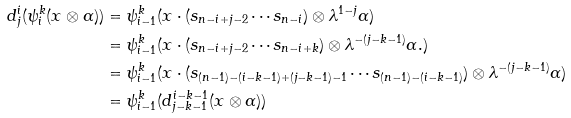<formula> <loc_0><loc_0><loc_500><loc_500>d ^ { i } _ { j } ( \psi ^ { k } _ { i } ( x \otimes \alpha ) ) & = \psi ^ { k } _ { i - 1 } ( x \cdot ( s _ { n - i + j - 2 } \cdots s _ { n - i } ) \otimes \lambda ^ { 1 - j } \alpha ) \\ & = \psi ^ { k } _ { i - 1 } ( x \cdot ( s _ { n - i + j - 2 } \cdots s _ { n - i + k } ) \otimes \lambda ^ { - ( j - k - 1 ) } \alpha . ) \\ & = \psi ^ { k } _ { i - 1 } ( x \cdot ( s _ { ( n - 1 ) - ( i - k - 1 ) + ( j - k - 1 ) - 1 } \cdots s _ { ( n - 1 ) - ( i - k - 1 ) } ) \otimes \lambda ^ { - ( j - k - 1 ) } \alpha ) \\ & = \psi ^ { k } _ { i - 1 } ( d ^ { i - k - 1 } _ { j - k - 1 } ( x \otimes \alpha ) )</formula> 